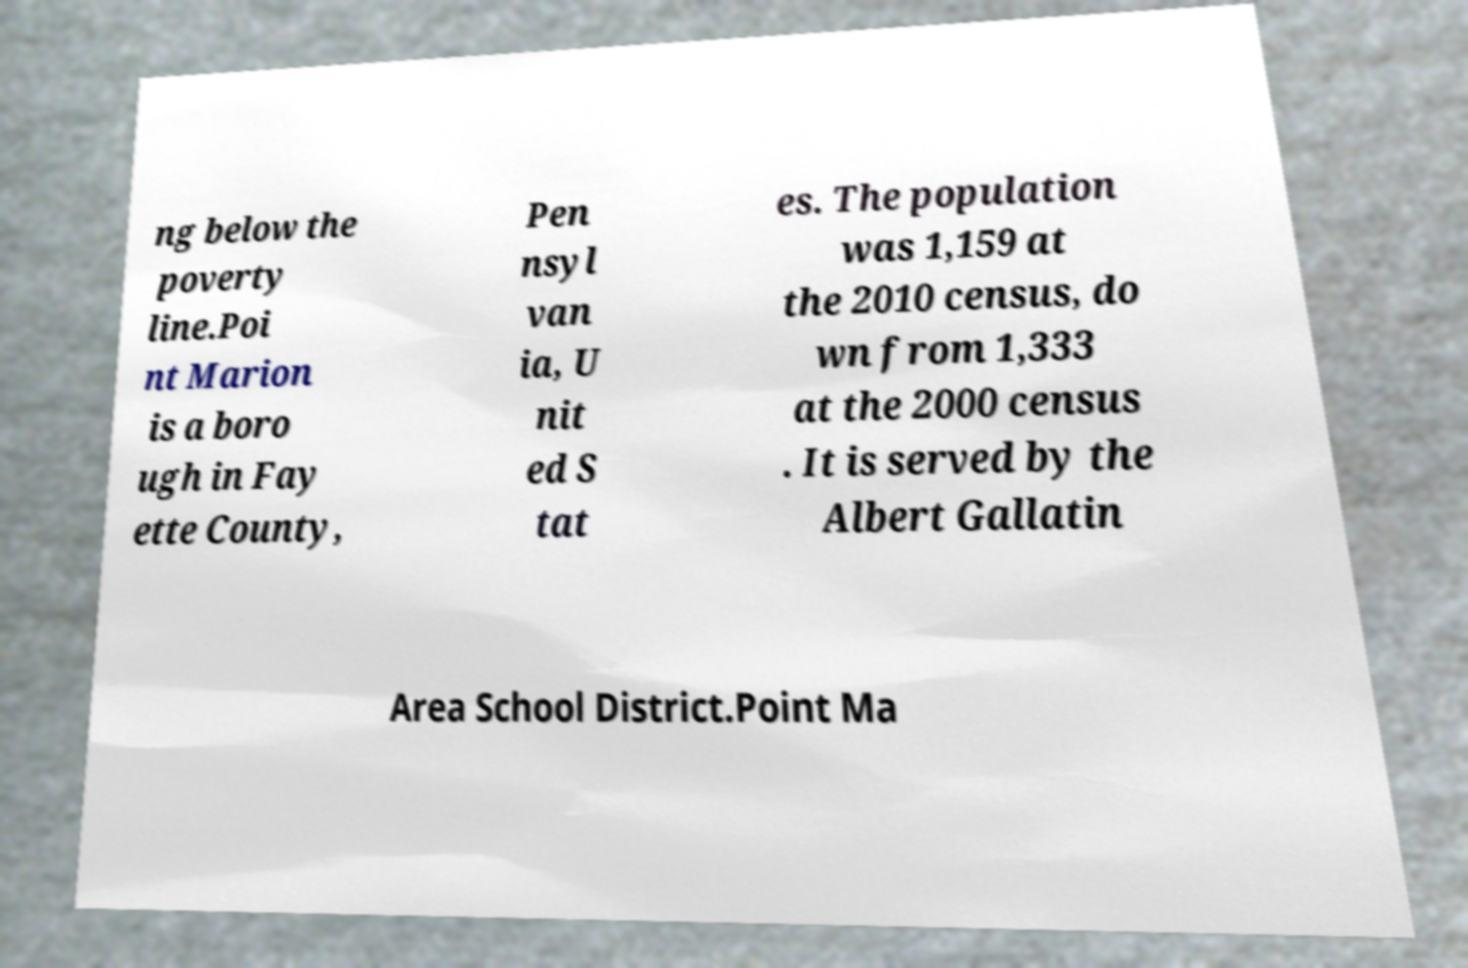For documentation purposes, I need the text within this image transcribed. Could you provide that? ng below the poverty line.Poi nt Marion is a boro ugh in Fay ette County, Pen nsyl van ia, U nit ed S tat es. The population was 1,159 at the 2010 census, do wn from 1,333 at the 2000 census . It is served by the Albert Gallatin Area School District.Point Ma 